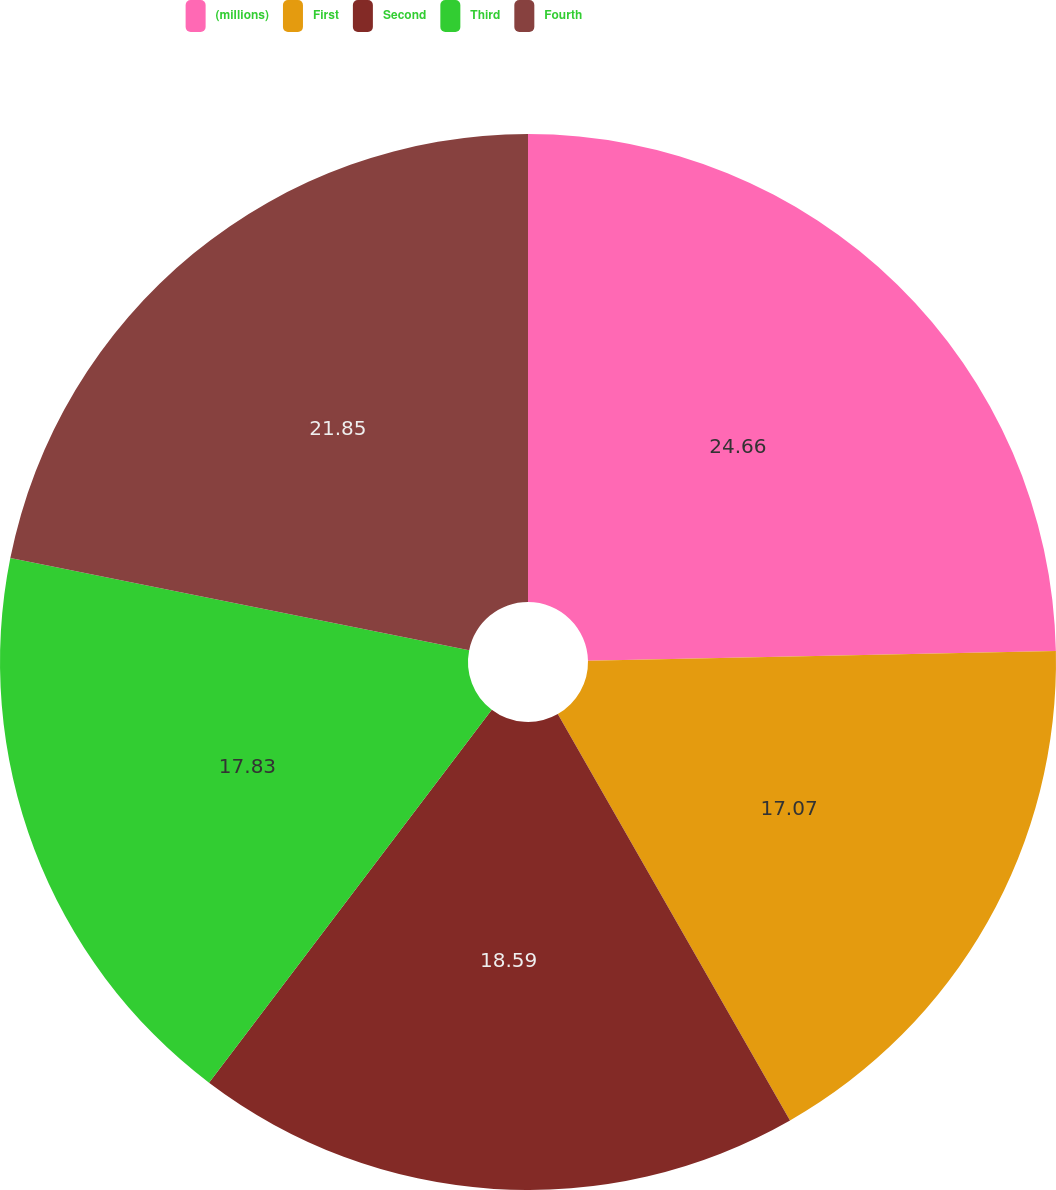Convert chart to OTSL. <chart><loc_0><loc_0><loc_500><loc_500><pie_chart><fcel>(millions)<fcel>First<fcel>Second<fcel>Third<fcel>Fourth<nl><fcel>24.67%<fcel>17.07%<fcel>18.59%<fcel>17.83%<fcel>21.85%<nl></chart> 